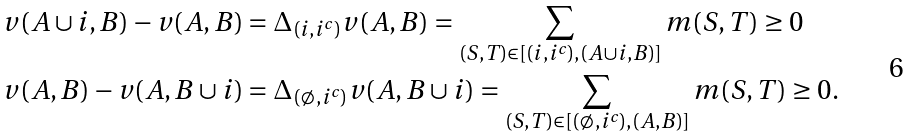<formula> <loc_0><loc_0><loc_500><loc_500>v ( A \cup i , B ) - v ( A , B ) & = \Delta _ { ( i , i ^ { c } ) } v ( A , B ) = \sum _ { ( S , T ) \in [ ( i , i ^ { c } ) , ( A \cup i , B ) ] } m ( S , T ) \geq 0 \\ v ( A , B ) - v ( A , B \cup i ) & = \Delta _ { ( \emptyset , i ^ { c } ) } v ( A , B \cup i ) = \sum _ { ( S , T ) \in [ ( \emptyset , i ^ { c } ) , ( A , B ) ] } m ( S , T ) \geq 0 .</formula> 